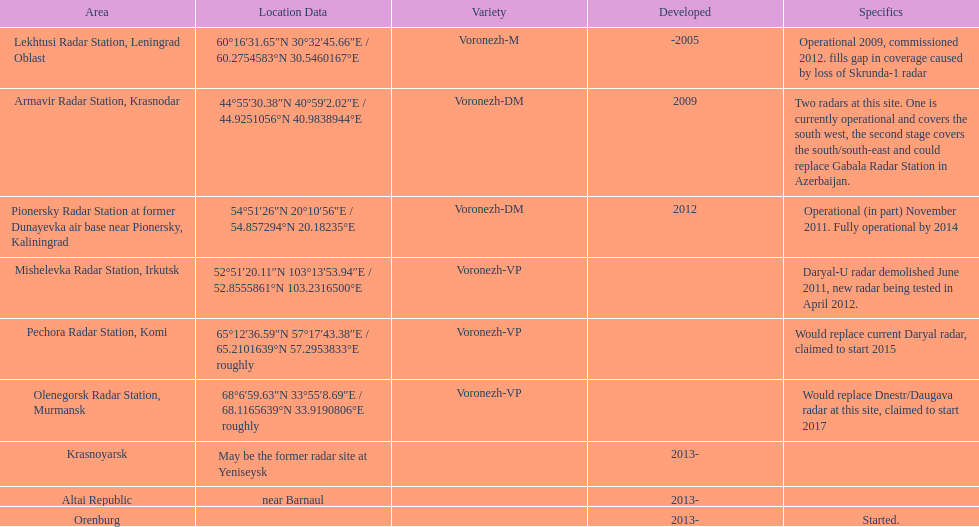How long did it take the pionersky radar station to go from partially operational to fully operational? 3 years. 